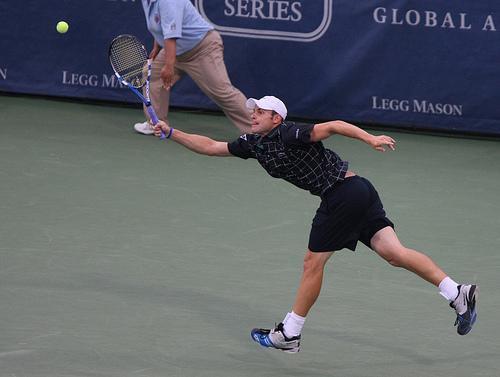How many tennis balls are there?
Give a very brief answer. 1. 